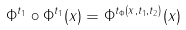<formula> <loc_0><loc_0><loc_500><loc_500>\Phi ^ { t _ { 1 } } \circ \Phi ^ { t _ { 1 } } ( x ) = \Phi ^ { t _ { \Phi } ( x , t _ { 1 } , t _ { 2 } ) } ( x )</formula> 